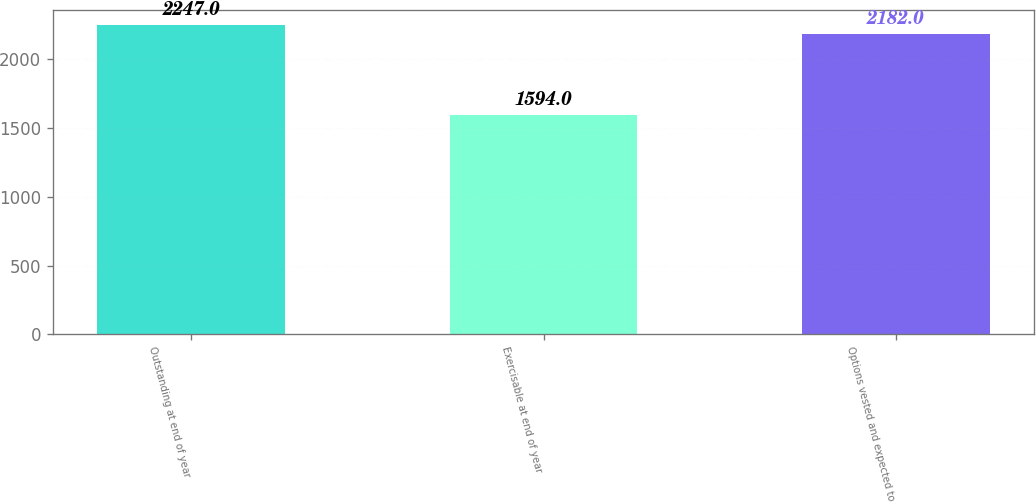Convert chart to OTSL. <chart><loc_0><loc_0><loc_500><loc_500><bar_chart><fcel>Outstanding at end of year<fcel>Exercisable at end of year<fcel>Options vested and expected to<nl><fcel>2247<fcel>1594<fcel>2182<nl></chart> 